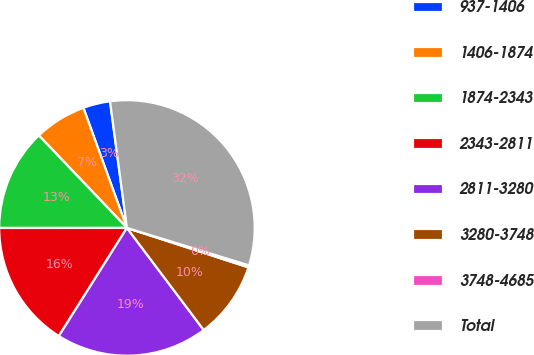Convert chart. <chart><loc_0><loc_0><loc_500><loc_500><pie_chart><fcel>937-1406<fcel>1406-1874<fcel>1874-2343<fcel>2343-2811<fcel>2811-3280<fcel>3280-3748<fcel>3748-4685<fcel>Total<nl><fcel>3.42%<fcel>6.58%<fcel>12.89%<fcel>16.05%<fcel>19.21%<fcel>9.74%<fcel>0.26%<fcel>31.85%<nl></chart> 